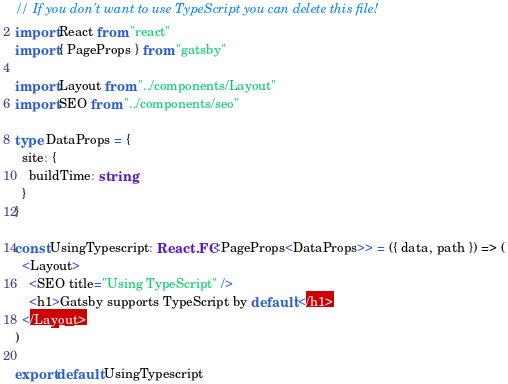Convert code to text. <code><loc_0><loc_0><loc_500><loc_500><_TypeScript_>// If you don't want to use TypeScript you can delete this file!
import React from "react"
import { PageProps } from "gatsby"

import Layout from "../components/Layout"
import SEO from "../components/seo"

type DataProps = {
  site: {
    buildTime: string
  }
}

const UsingTypescript: React.FC<PageProps<DataProps>> = ({ data, path }) => (
  <Layout>
    <SEO title="Using TypeScript" />
    <h1>Gatsby supports TypeScript by default!</h1>
  </Layout>
)

export default UsingTypescript

</code> 